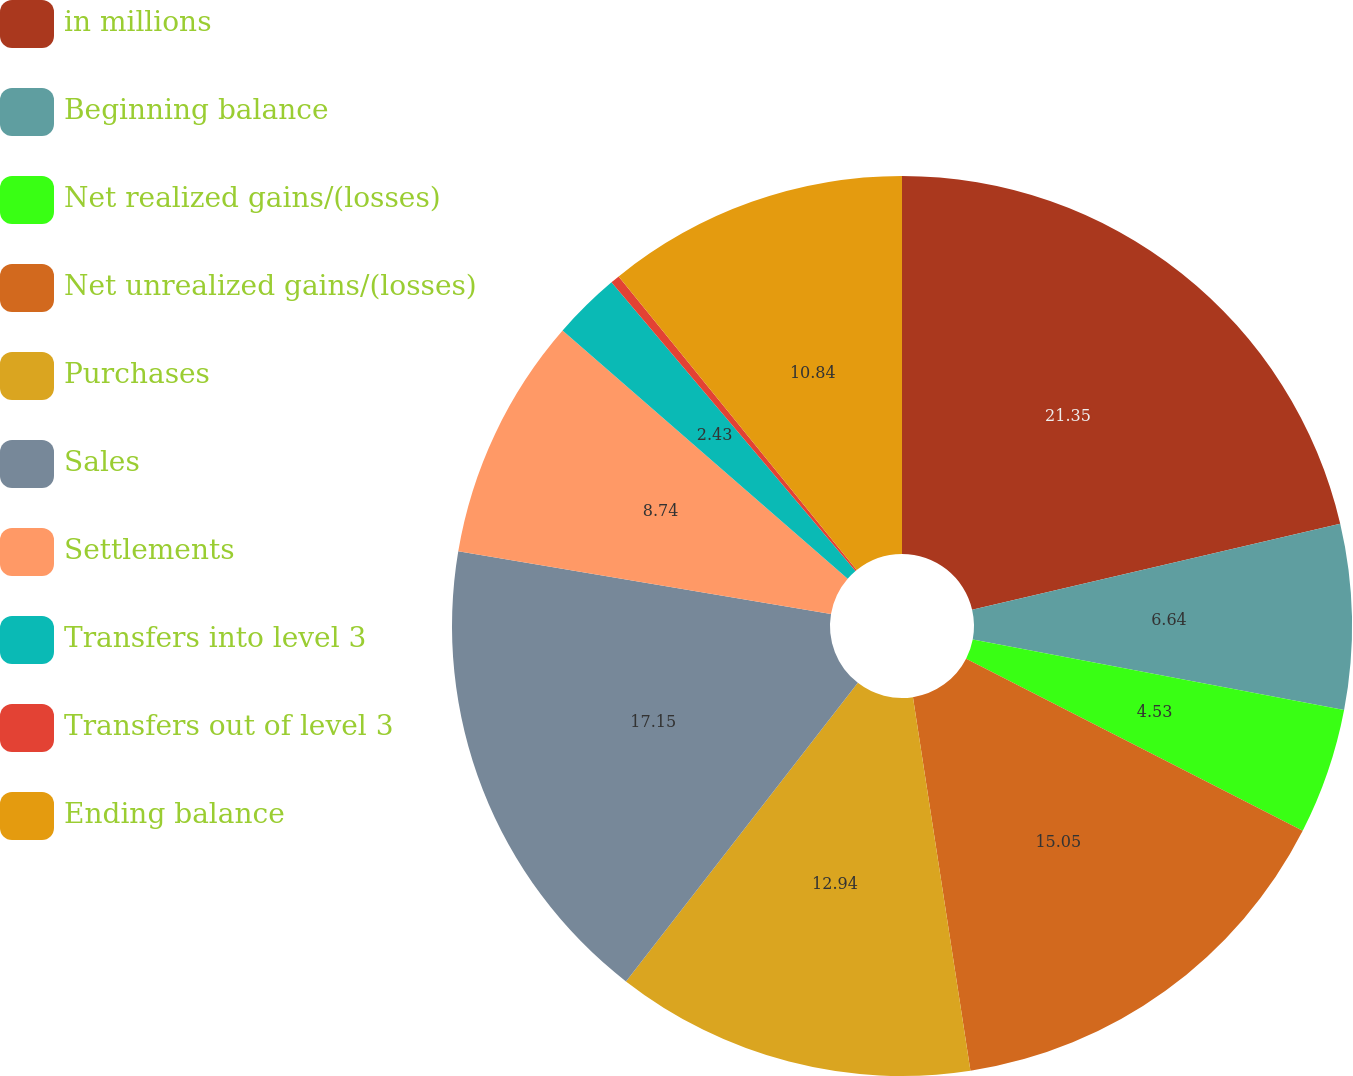<chart> <loc_0><loc_0><loc_500><loc_500><pie_chart><fcel>in millions<fcel>Beginning balance<fcel>Net realized gains/(losses)<fcel>Net unrealized gains/(losses)<fcel>Purchases<fcel>Sales<fcel>Settlements<fcel>Transfers into level 3<fcel>Transfers out of level 3<fcel>Ending balance<nl><fcel>21.35%<fcel>6.64%<fcel>4.53%<fcel>15.05%<fcel>12.94%<fcel>17.15%<fcel>8.74%<fcel>2.43%<fcel>0.33%<fcel>10.84%<nl></chart> 